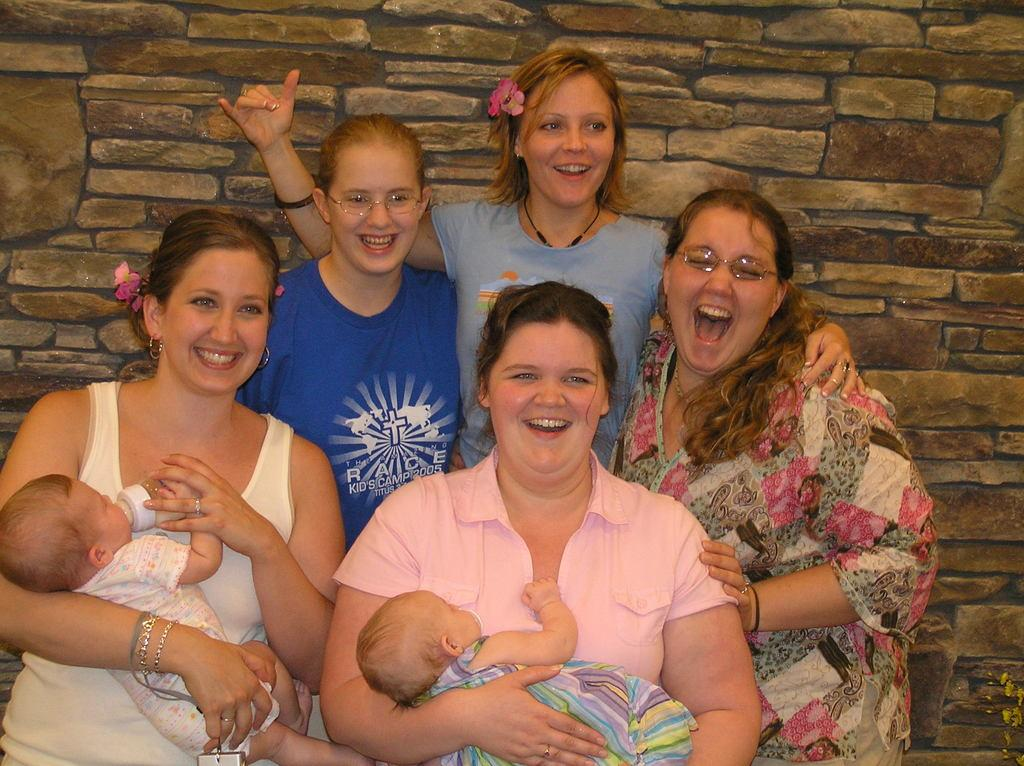How many people are in the image? There is a group of persons in the image. What are the people in the image doing? The persons are smiling and standing. Can you describe any specific interactions between the people in the image? Two of the persons are holding babies. What can be seen in the background of the image? There is a stone wall in the background of the image. What type of cream can be seen on the farmer's hands in the image? There is no farmer or cream present in the image. What songs are the people singing in the image? There is no indication in the image that the people are singing any songs. 